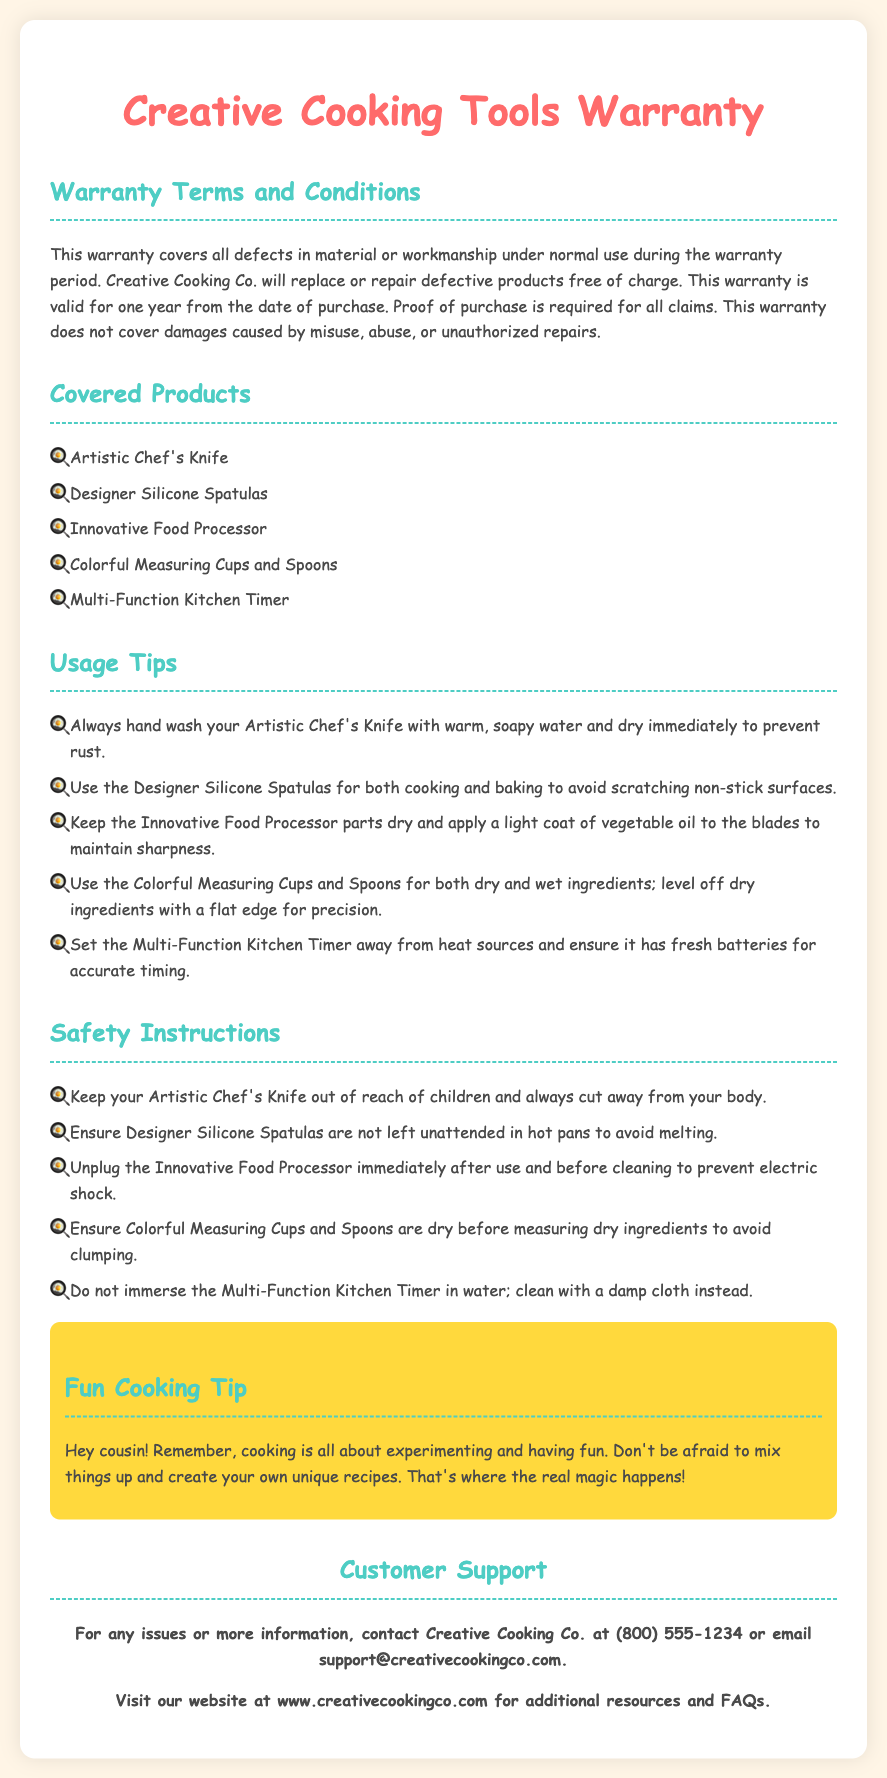What is the warranty period? The warranty is valid for one year from the date of purchase.
Answer: one year Which product requires immediate unplugging after use? The Innovative Food Processor should be unplugged immediately after use.
Answer: Innovative Food Processor What is needed to make a warranty claim? Proof of purchase is required for all claims.
Answer: Proof of purchase What should you do to maintain the sharpness of the food processor blades? Apply a light coat of vegetable oil to the blades.
Answer: vegetable oil Which organization provides customer support? Creative Cooking Co. provides customer support.
Answer: Creative Cooking Co What should you not immerse in water? Do not immerse the Multi-Function Kitchen Timer in water.
Answer: Multi-Function Kitchen Timer What is recommended for measuring dry ingredients? Ensure Colorful Measuring Cups and Spoons are dry before measuring dry ingredients.
Answer: Colorful Measuring Cups and Spoons What should you do with the Artistic Chef's Knife to prevent rust? Always hand wash your Artistic Chef's Knife with warm, soapy water and dry immediately.
Answer: hand wash and dry immediately 